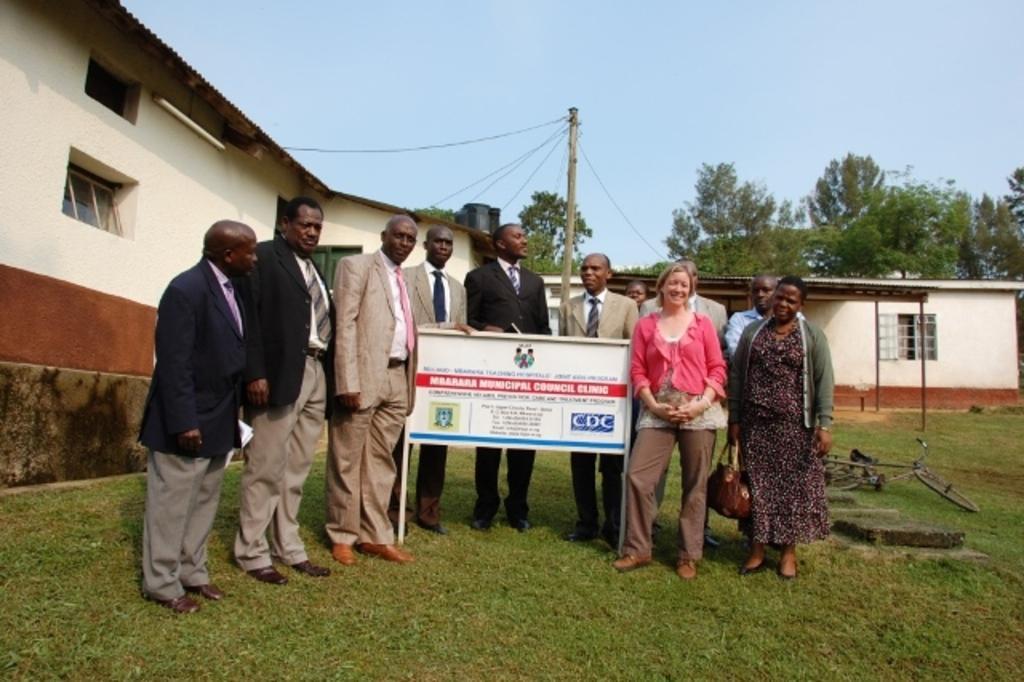How would you summarize this image in a sentence or two? In this image we can see a group of people standing on the ground and a signboard with some text on it. We can also see some grass, a bicycle on the ground, some houses with windows, a tube light on a wall, some trees, poles, a pole with some wires and the sky which looks cloudy. 